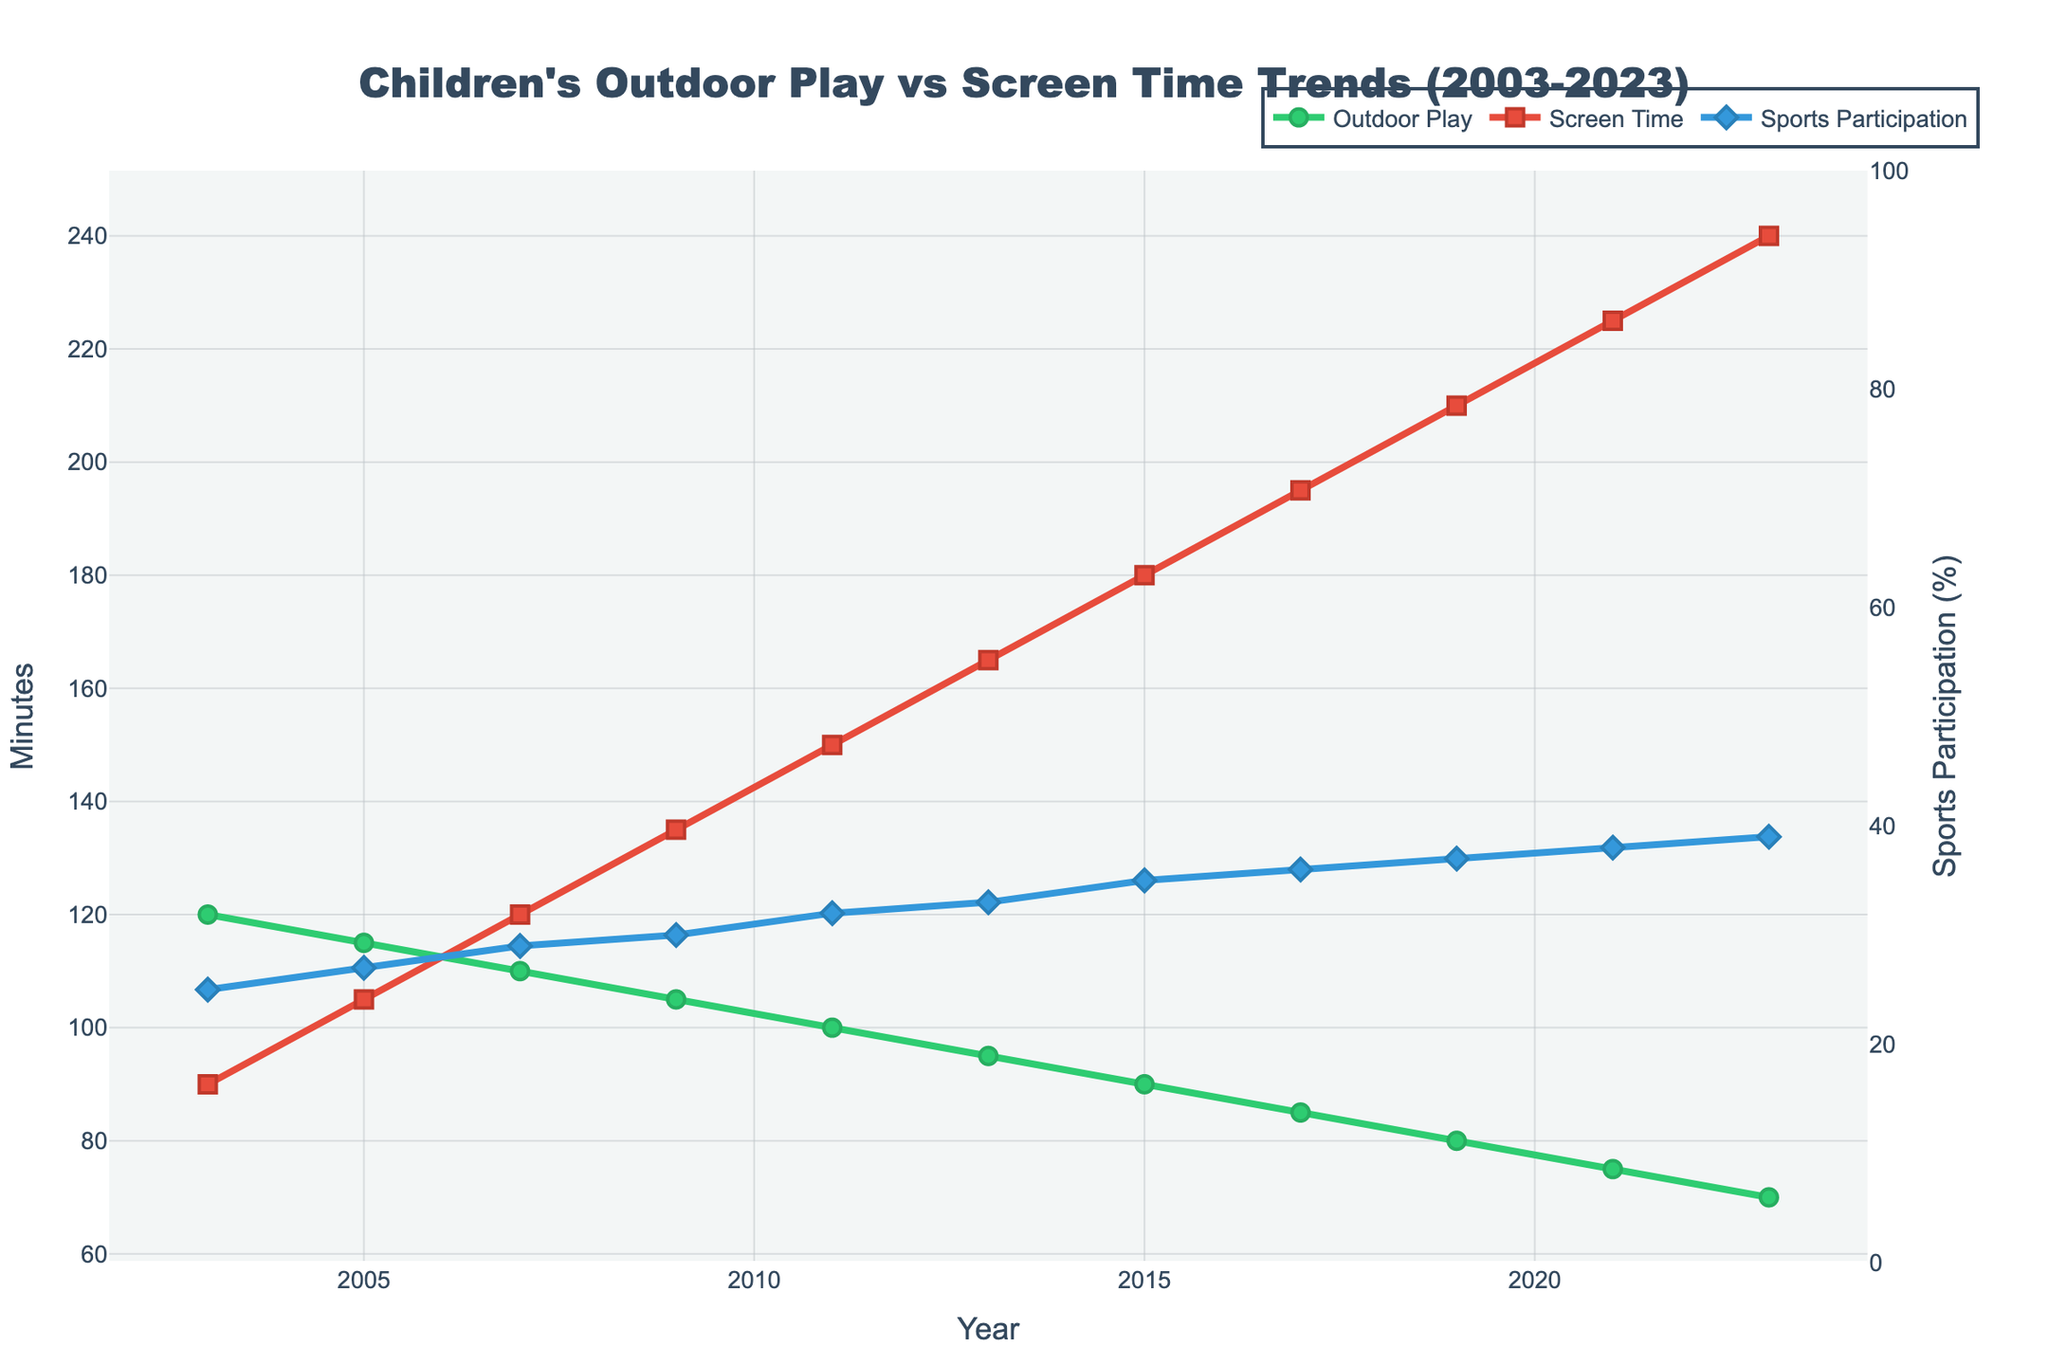What is the general trend in children's outdoor playtime over the last 20 years? The general trend shows a continuous decline in children's outdoor playtime from 120 minutes in 2003 to 70 minutes in 2023.
Answer: Decline Which year had the highest screen time for children? By examining the red line representing screen time, the highest point is at 240 minutes in the year 2023.
Answer: 2023 How did organized sports participation change from 2003 to 2023? The blue line indicating sports participation starts at 25% in 2003 and rises steadily to 39% in 2023.
Answer: Increased What is the difference between park play and backyard play as a percentage of total outdoor play in 2023? The percentage of backyard play in 2023 is 54%, and the percentage of park play is 20%. The difference is 54% - 20% = 34%.
Answer: 34% During which years did screen time exceed outdoor playtime? Screen time exceeds outdoor playtime from 2013 onwards, as the red line lies above the green line in the graph starting from this year.
Answer: 2013 - 2023 In which year was the gap between screen time and outdoor playtime the largest, and what was the difference? The largest gap can be observed in 2023, where screen time is 240 minutes and outdoor playtime is 70 minutes. The difference is 240 - 70 = 170 minutes.
Answer: 2023, 170 minutes Compare the trend of backyard play and park play percentages over the 20 years. Over the 20 years, the percentage of backyard play increased from 35% to 54%, while the percentage of park play decreased from 45% to 20%, as indicated by the changes in the respective line segments on the plot.
Answer: Backyard play increased, park play decreased Calculate the average screen time for the years 2011 to 2023. The screen time values for 2011, 2013, 2015, 2017, 2019, 2021, and 2023 are 150, 165, 180, 195, 210, 225, and 240 minutes respectively. The sum is 1365, and the number of years is 7. The average is 1365 / 7 ≈ 195 minutes.
Answer: 195 minutes How does the trend in organized sports participation compare to the trend in outdoor playtime from 2003 to 2023? Organized sports participation shows a steady increase from 25% to 39%, while outdoor playtime shows a continuous decline from 120 minutes to 70 minutes. These trends are inversely related.
Answer: Inverse trend 